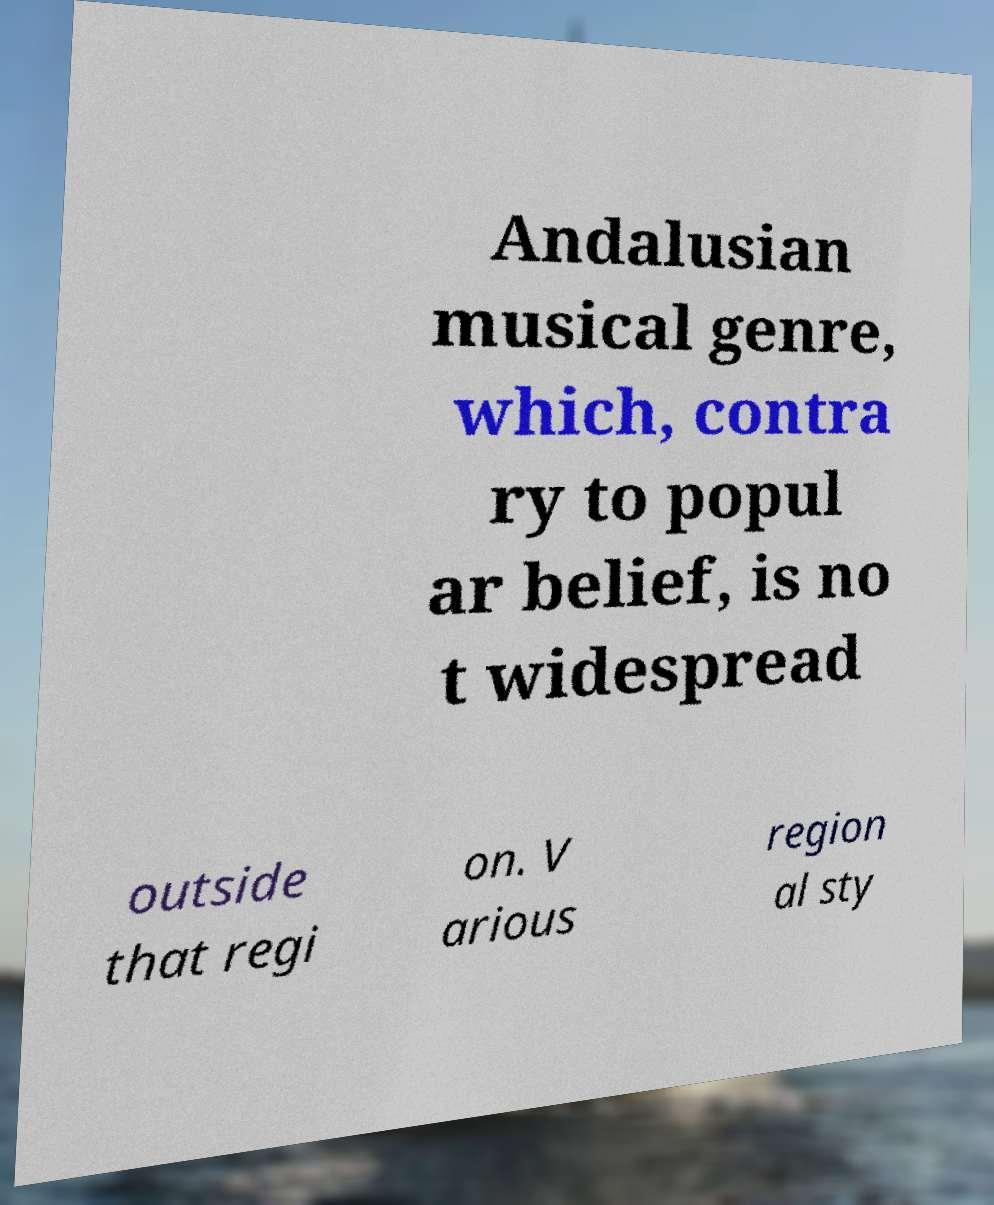Can you accurately transcribe the text from the provided image for me? Andalusian musical genre, which, contra ry to popul ar belief, is no t widespread outside that regi on. V arious region al sty 